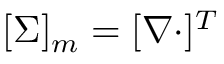<formula> <loc_0><loc_0><loc_500><loc_500>[ \Sigma ] _ { m } = [ \nabla \cdot ] ^ { T }</formula> 